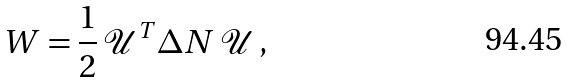<formula> <loc_0><loc_0><loc_500><loc_500>W = \frac { 1 } { 2 } \, \mathcal { U } ^ { T } \Delta N \, \mathcal { U } \, ,</formula> 